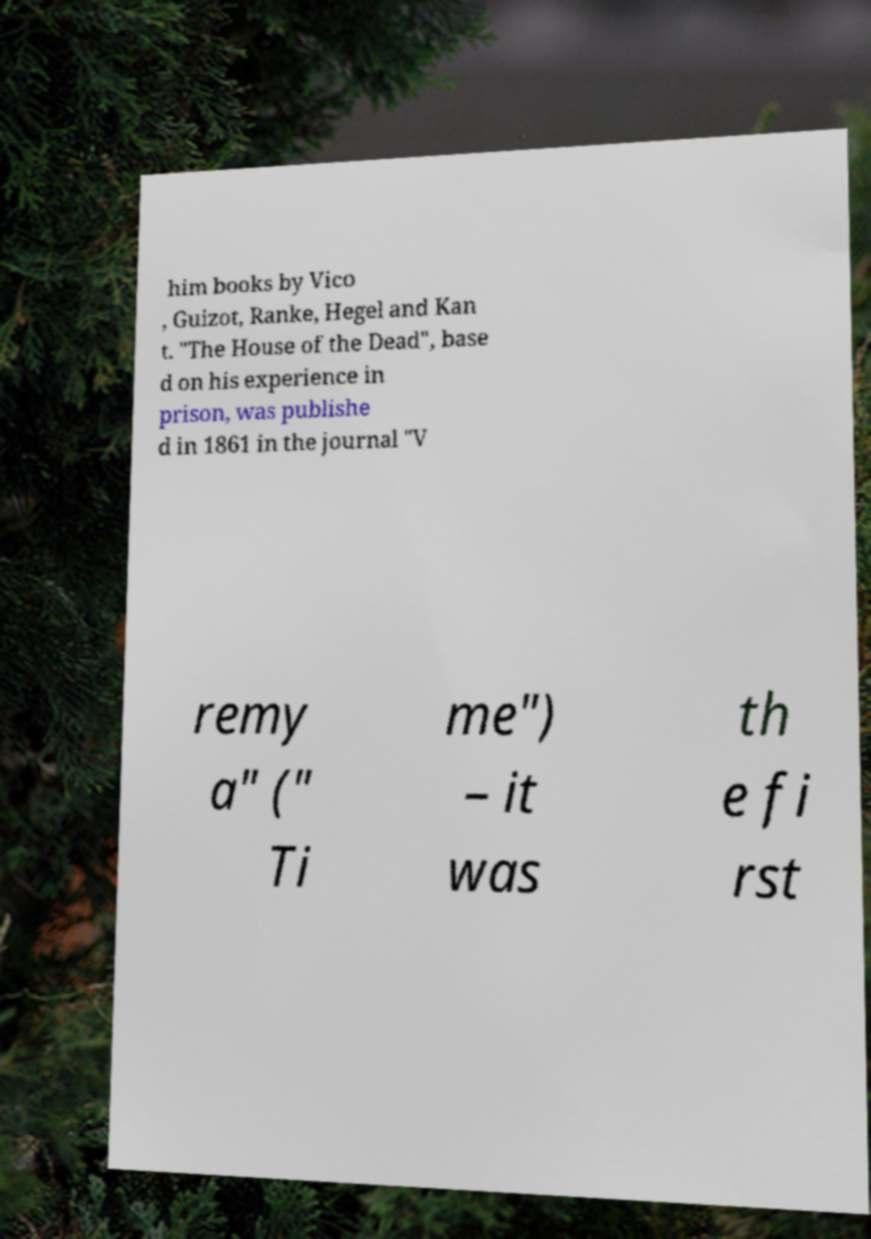I need the written content from this picture converted into text. Can you do that? him books by Vico , Guizot, Ranke, Hegel and Kan t. "The House of the Dead", base d on his experience in prison, was publishe d in 1861 in the journal "V remy a" (" Ti me") – it was th e fi rst 